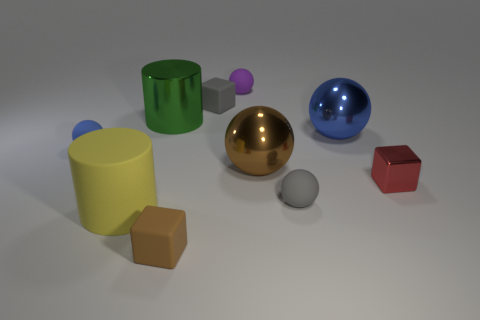Which objects in the image are reflective? The gold and blue spheres exhibit a high level of reflectiveness, which you can tell by the light and the environment reflecting off their surfaces. 